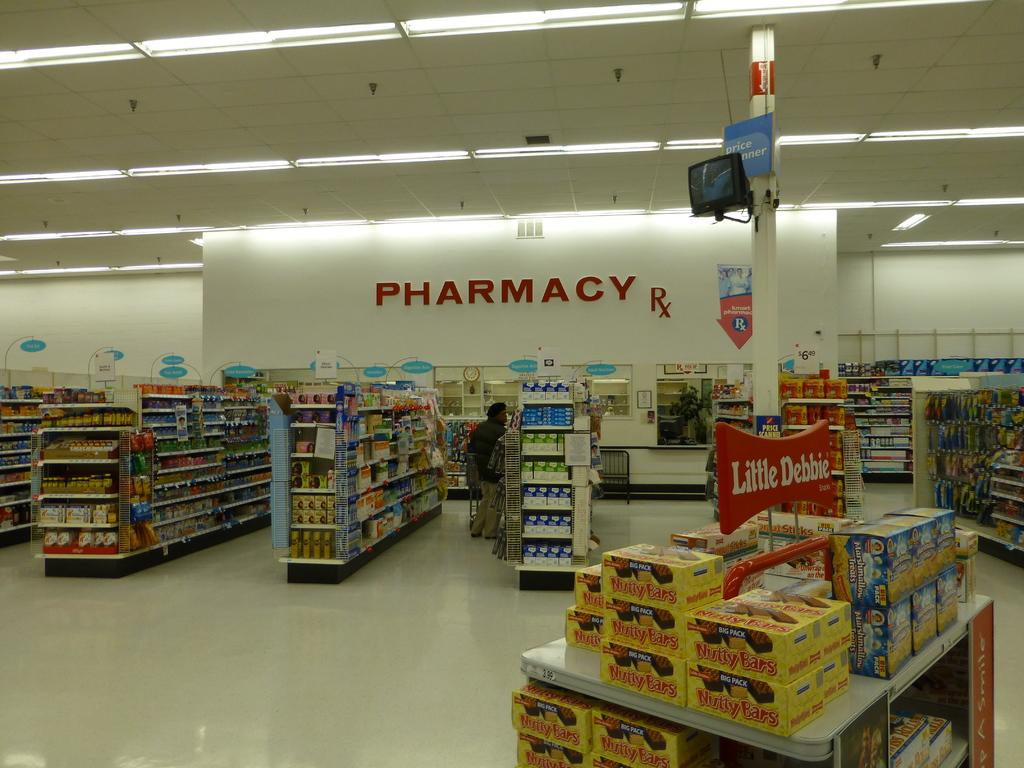<image>
Write a terse but informative summary of the picture. A pharmacy sign inside of a grocery store showcasing many products. 